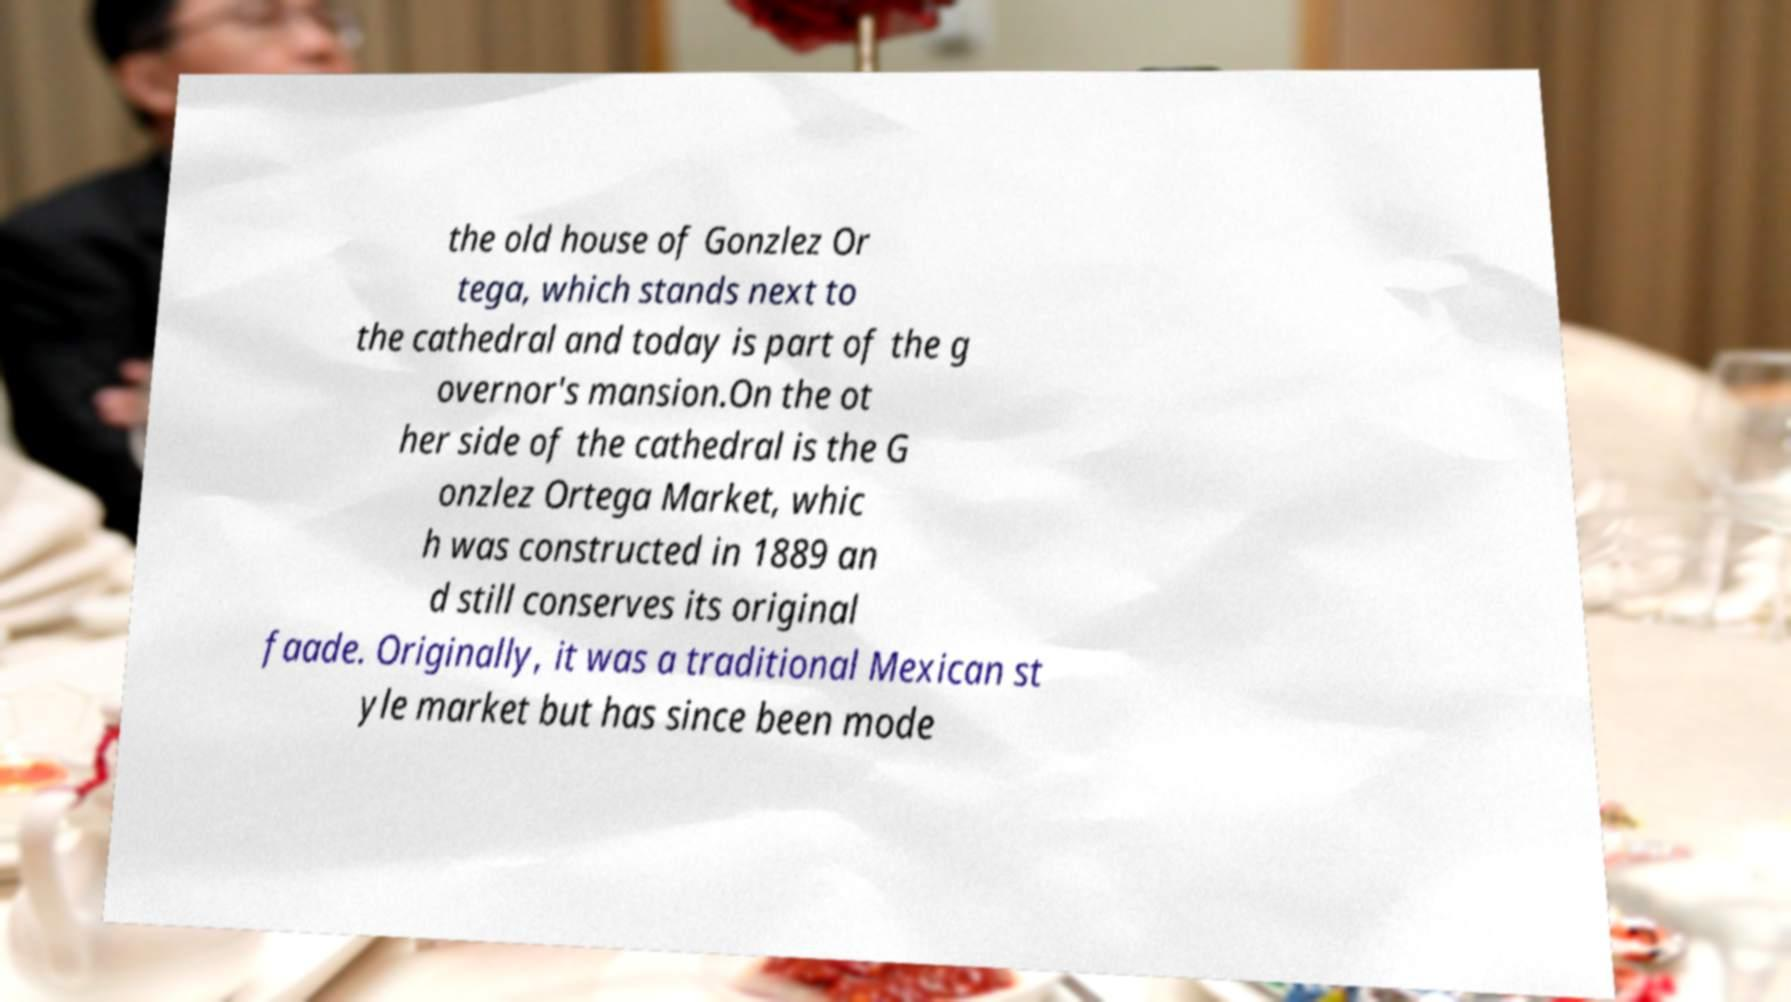Can you accurately transcribe the text from the provided image for me? the old house of Gonzlez Or tega, which stands next to the cathedral and today is part of the g overnor's mansion.On the ot her side of the cathedral is the G onzlez Ortega Market, whic h was constructed in 1889 an d still conserves its original faade. Originally, it was a traditional Mexican st yle market but has since been mode 